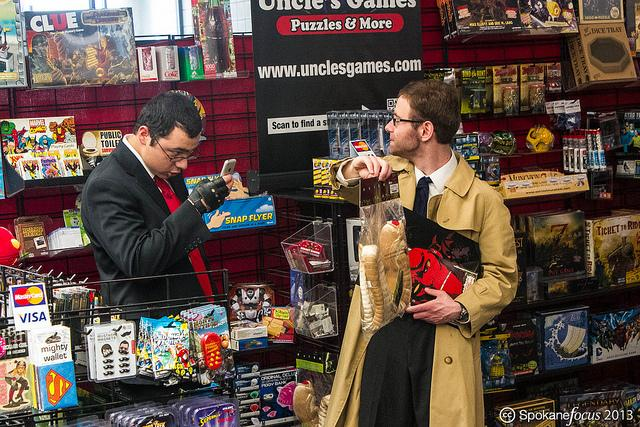What superhero's logo is printed on a wallet in front of the Visa sign?

Choices:
A) wonder woman
B) green lantern
C) superman
D) batman superman 